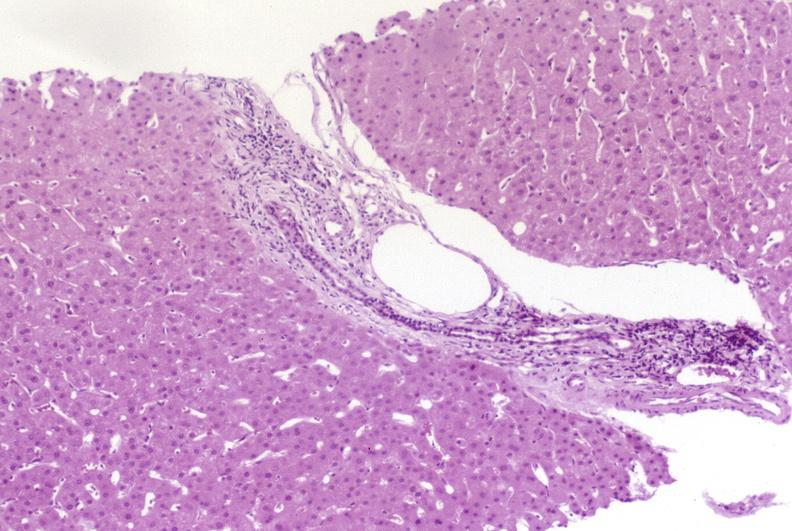does acute lymphocytic leukemia show resolving acute rejection?
Answer the question using a single word or phrase. No 